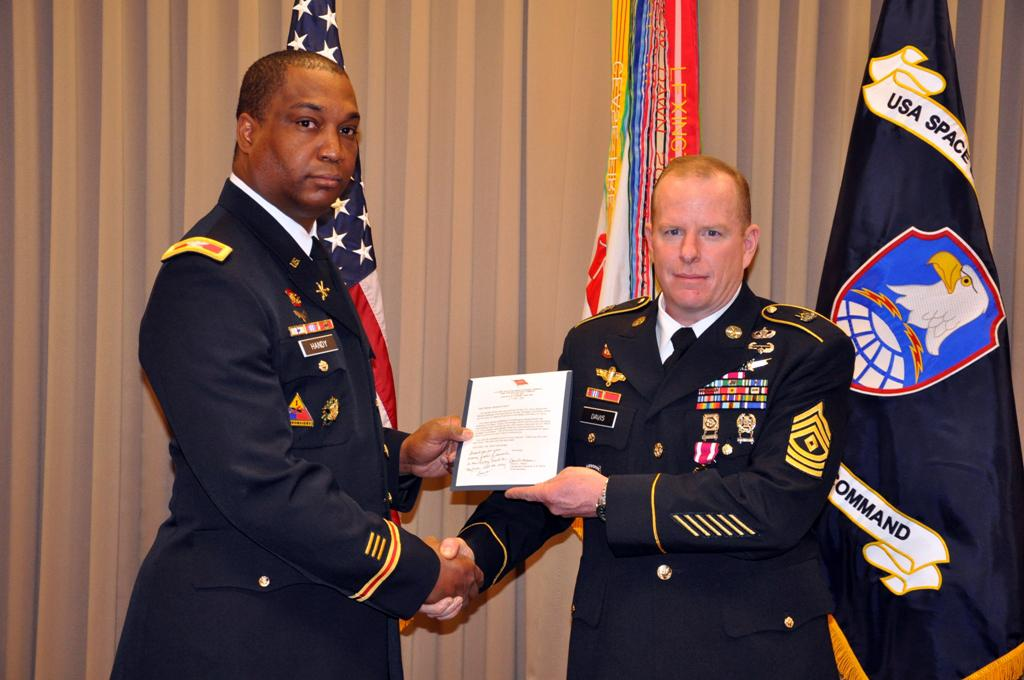<image>
Provide a brief description of the given image. Two soldiers posing in front of a flag that says USA on it. 